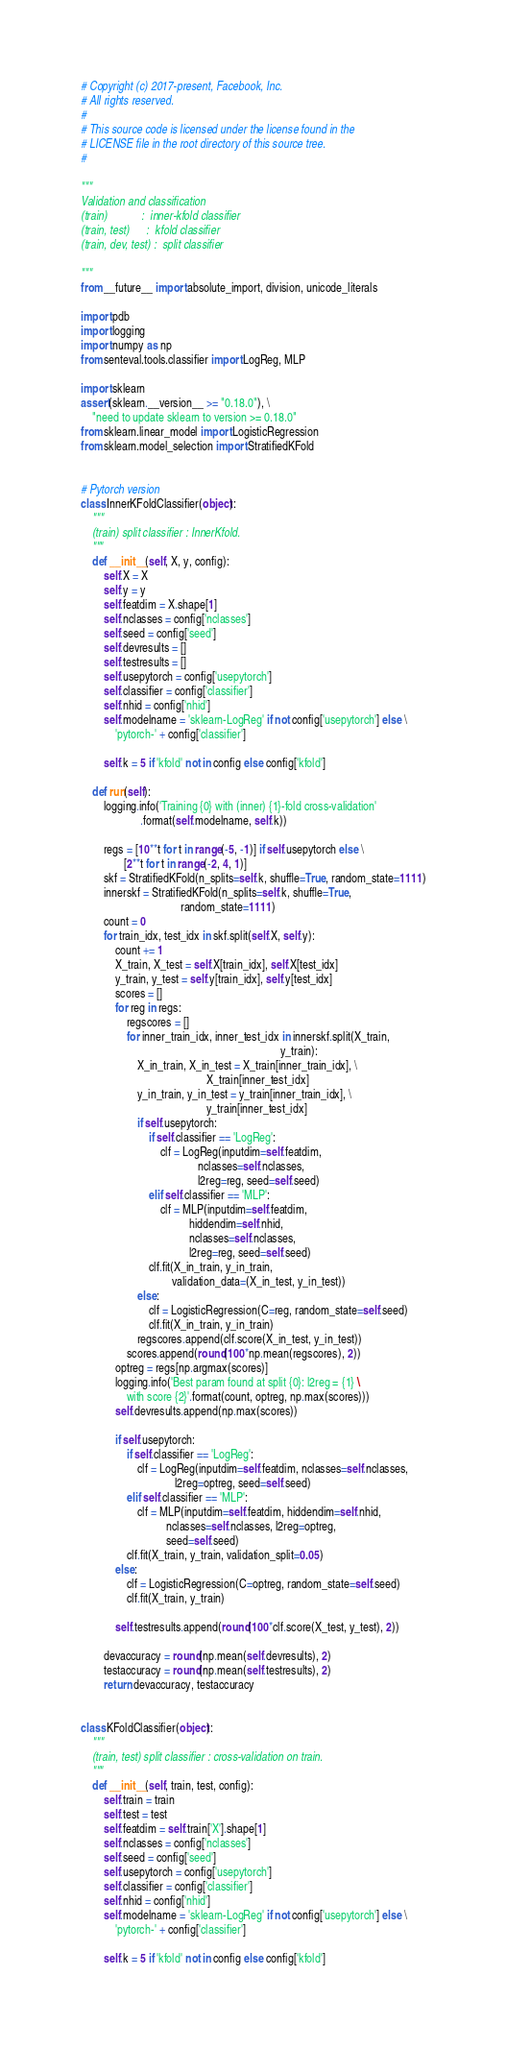Convert code to text. <code><loc_0><loc_0><loc_500><loc_500><_Python_># Copyright (c) 2017-present, Facebook, Inc.
# All rights reserved.
#
# This source code is licensed under the license found in the
# LICENSE file in the root directory of this source tree.
#

"""
Validation and classification
(train)            :  inner-kfold classifier
(train, test)      :  kfold classifier
(train, dev, test) :  split classifier

"""
from __future__ import absolute_import, division, unicode_literals

import pdb
import logging
import numpy as np
from senteval.tools.classifier import LogReg, MLP

import sklearn
assert(sklearn.__version__ >= "0.18.0"), \
    "need to update sklearn to version >= 0.18.0"
from sklearn.linear_model import LogisticRegression
from sklearn.model_selection import StratifiedKFold


# Pytorch version
class InnerKFoldClassifier(object):
    """
    (train) split classifier : InnerKfold.
    """
    def __init__(self, X, y, config):
        self.X = X
        self.y = y
        self.featdim = X.shape[1]
        self.nclasses = config['nclasses']
        self.seed = config['seed']
        self.devresults = []
        self.testresults = []
        self.usepytorch = config['usepytorch']
        self.classifier = config['classifier']
        self.nhid = config['nhid']
        self.modelname = 'sklearn-LogReg' if not config['usepytorch'] else \
            'pytorch-' + config['classifier']

        self.k = 5 if 'kfold' not in config else config['kfold']

    def run(self):
        logging.info('Training {0} with (inner) {1}-fold cross-validation'
                     .format(self.modelname, self.k))

        regs = [10**t for t in range(-5, -1)] if self.usepytorch else \
               [2**t for t in range(-2, 4, 1)]
        skf = StratifiedKFold(n_splits=self.k, shuffle=True, random_state=1111)
        innerskf = StratifiedKFold(n_splits=self.k, shuffle=True,
                                   random_state=1111)
        count = 0
        for train_idx, test_idx in skf.split(self.X, self.y):
            count += 1
            X_train, X_test = self.X[train_idx], self.X[test_idx]
            y_train, y_test = self.y[train_idx], self.y[test_idx]
            scores = []
            for reg in regs:
                regscores = []
                for inner_train_idx, inner_test_idx in innerskf.split(X_train,
                                                                      y_train):
                    X_in_train, X_in_test = X_train[inner_train_idx], \
                                            X_train[inner_test_idx]
                    y_in_train, y_in_test = y_train[inner_train_idx], \
                                            y_train[inner_test_idx]
                    if self.usepytorch:
                        if self.classifier == 'LogReg':
                            clf = LogReg(inputdim=self.featdim,
                                         nclasses=self.nclasses,
                                         l2reg=reg, seed=self.seed)
                        elif self.classifier == 'MLP':
                            clf = MLP(inputdim=self.featdim,
                                      hiddendim=self.nhid,
                                      nclasses=self.nclasses,
                                      l2reg=reg, seed=self.seed)
                        clf.fit(X_in_train, y_in_train,
                                validation_data=(X_in_test, y_in_test))
                    else:
                        clf = LogisticRegression(C=reg, random_state=self.seed)
                        clf.fit(X_in_train, y_in_train)
                    regscores.append(clf.score(X_in_test, y_in_test))
                scores.append(round(100*np.mean(regscores), 2))
            optreg = regs[np.argmax(scores)]
            logging.info('Best param found at split {0}: l2reg = {1} \
                with score {2}'.format(count, optreg, np.max(scores)))
            self.devresults.append(np.max(scores))

            if self.usepytorch:
                if self.classifier == 'LogReg':
                    clf = LogReg(inputdim=self.featdim, nclasses=self.nclasses,
                                 l2reg=optreg, seed=self.seed)
                elif self.classifier == 'MLP':
                    clf = MLP(inputdim=self.featdim, hiddendim=self.nhid,
                              nclasses=self.nclasses, l2reg=optreg,
                              seed=self.seed)
                clf.fit(X_train, y_train, validation_split=0.05)
            else:
                clf = LogisticRegression(C=optreg, random_state=self.seed)
                clf.fit(X_train, y_train)

            self.testresults.append(round(100*clf.score(X_test, y_test), 2))

        devaccuracy = round(np.mean(self.devresults), 2)
        testaccuracy = round(np.mean(self.testresults), 2)
        return devaccuracy, testaccuracy


class KFoldClassifier(object):
    """
    (train, test) split classifier : cross-validation on train.
    """
    def __init__(self, train, test, config):
        self.train = train
        self.test = test
        self.featdim = self.train['X'].shape[1]
        self.nclasses = config['nclasses']
        self.seed = config['seed']
        self.usepytorch = config['usepytorch']
        self.classifier = config['classifier']
        self.nhid = config['nhid']
        self.modelname = 'sklearn-LogReg' if not config['usepytorch'] else \
            'pytorch-' + config['classifier']

        self.k = 5 if 'kfold' not in config else config['kfold']
</code> 